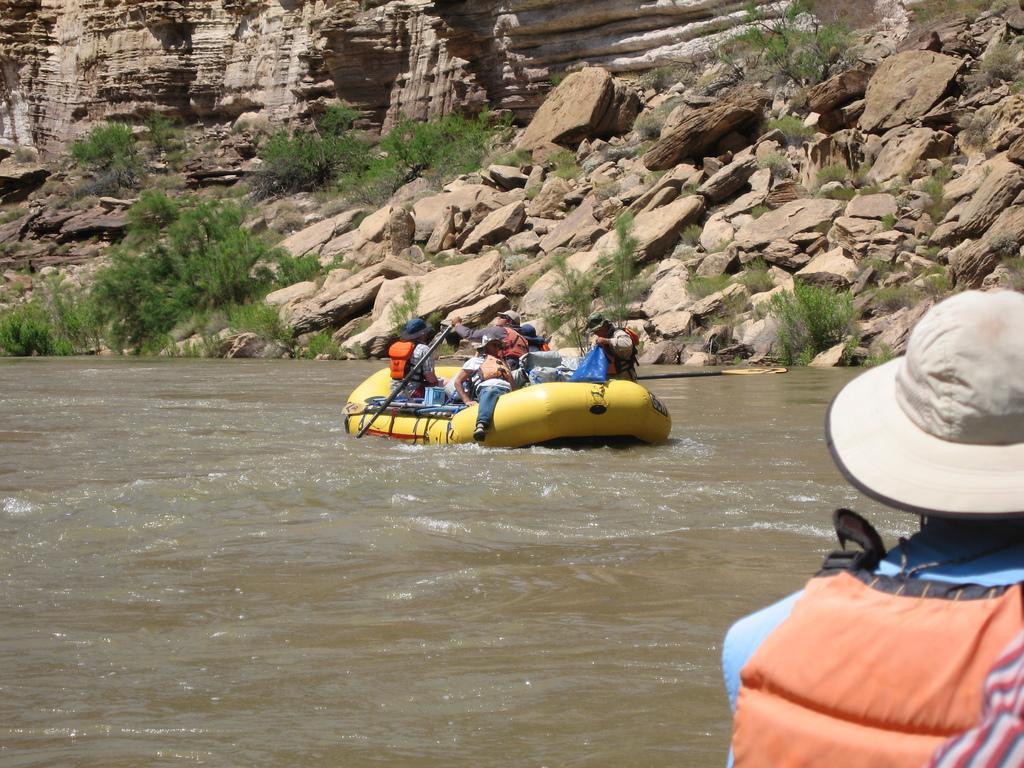Please provide a concise description of this image. In this image there is water on which there is a inflatable boat. In the boat there are few people sitting on it. On the right side bottom there is a man who is wearing the jacket and a cap. In the background there are stones and small plants. On the left side top there is a stone wall. 